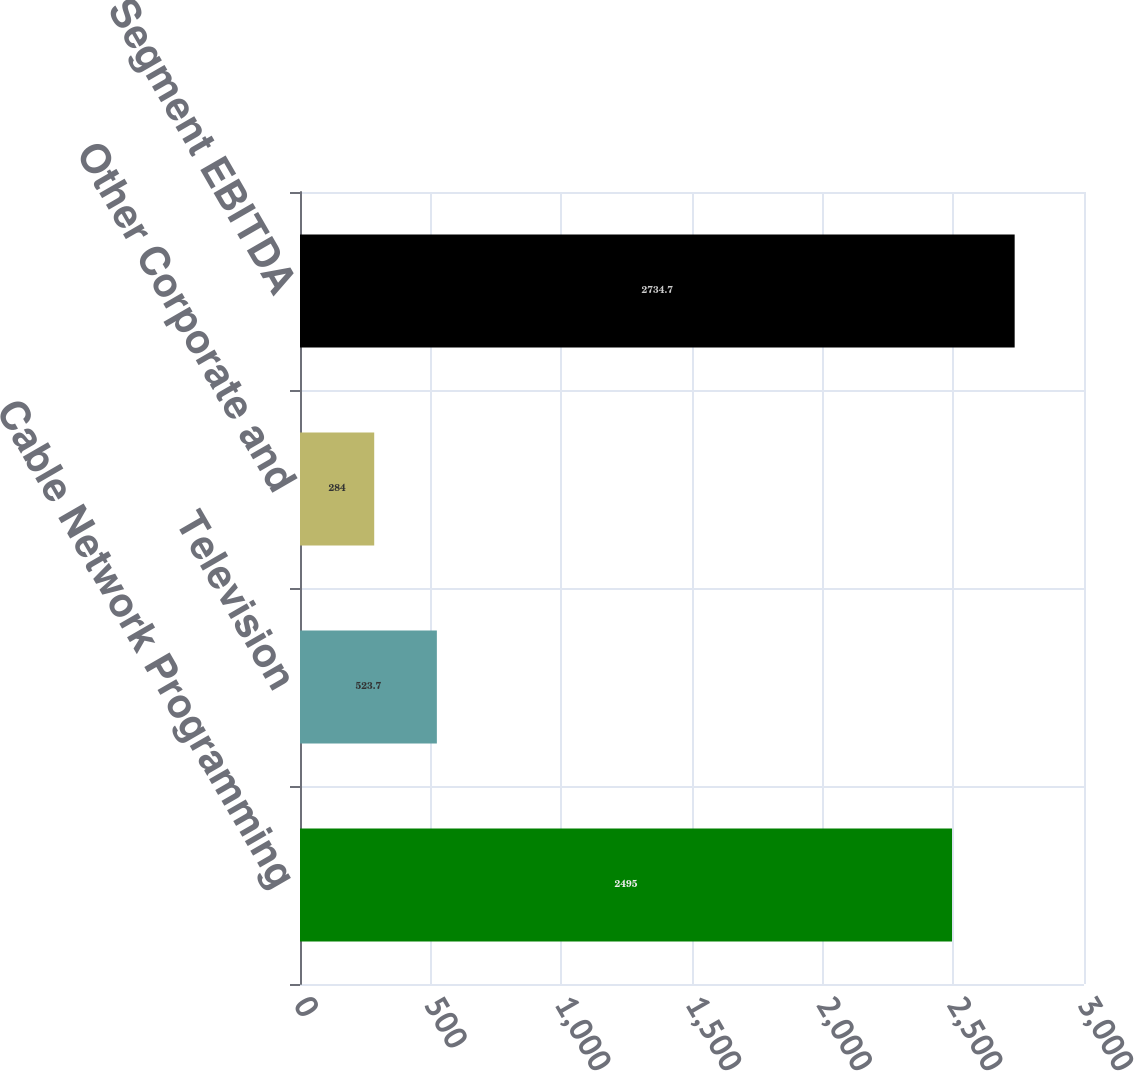<chart> <loc_0><loc_0><loc_500><loc_500><bar_chart><fcel>Cable Network Programming<fcel>Television<fcel>Other Corporate and<fcel>Total Segment EBITDA<nl><fcel>2495<fcel>523.7<fcel>284<fcel>2734.7<nl></chart> 